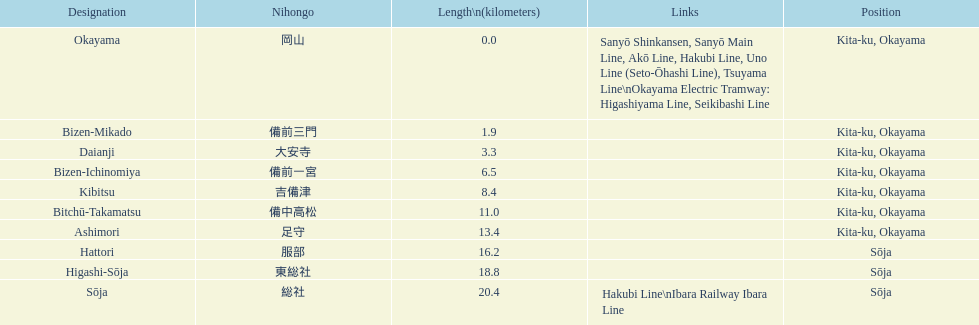Can you give me this table as a dict? {'header': ['Designation', 'Nihongo', 'Length\\n(kilometers)', 'Links', 'Position'], 'rows': [['Okayama', '岡山', '0.0', 'Sanyō Shinkansen, Sanyō Main Line, Akō Line, Hakubi Line, Uno Line (Seto-Ōhashi Line), Tsuyama Line\\nOkayama Electric Tramway: Higashiyama Line, Seikibashi Line', 'Kita-ku, Okayama'], ['Bizen-Mikado', '備前三門', '1.9', '', 'Kita-ku, Okayama'], ['Daianji', '大安寺', '3.3', '', 'Kita-ku, Okayama'], ['Bizen-Ichinomiya', '備前一宮', '6.5', '', 'Kita-ku, Okayama'], ['Kibitsu', '吉備津', '8.4', '', 'Kita-ku, Okayama'], ['Bitchū-Takamatsu', '備中高松', '11.0', '', 'Kita-ku, Okayama'], ['Ashimori', '足守', '13.4', '', 'Kita-ku, Okayama'], ['Hattori', '服部', '16.2', '', 'Sōja'], ['Higashi-Sōja', '東総社', '18.8', '', 'Sōja'], ['Sōja', '総社', '20.4', 'Hakubi Line\\nIbara Railway Ibara Line', 'Sōja']]} Which has a distance less than 3.0 kilometers? Bizen-Mikado. 